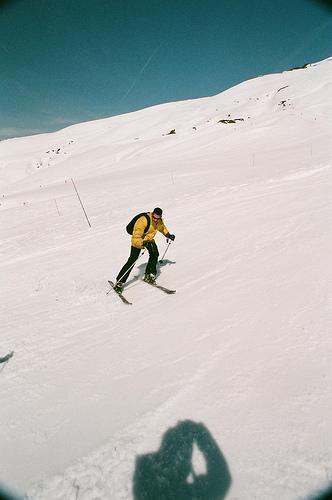How many skiers are there?
Give a very brief answer. 1. How many people are playing football?
Give a very brief answer. 0. 